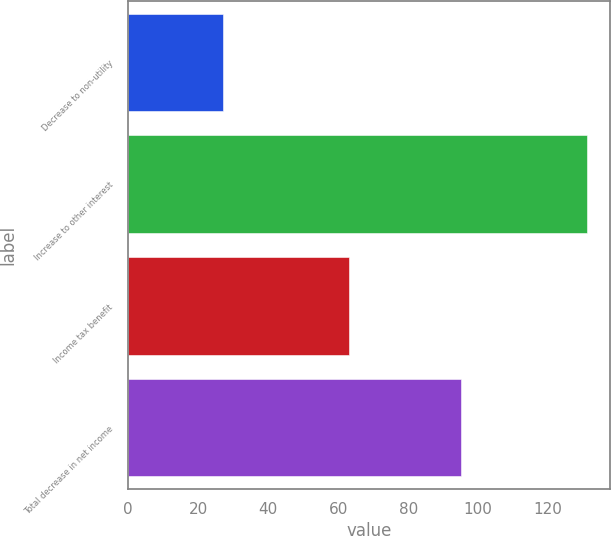Convert chart to OTSL. <chart><loc_0><loc_0><loc_500><loc_500><bar_chart><fcel>Decrease to non-utility<fcel>Increase to other interest<fcel>Income tax benefit<fcel>Total decrease in net income<nl><fcel>27<fcel>131<fcel>63<fcel>95<nl></chart> 